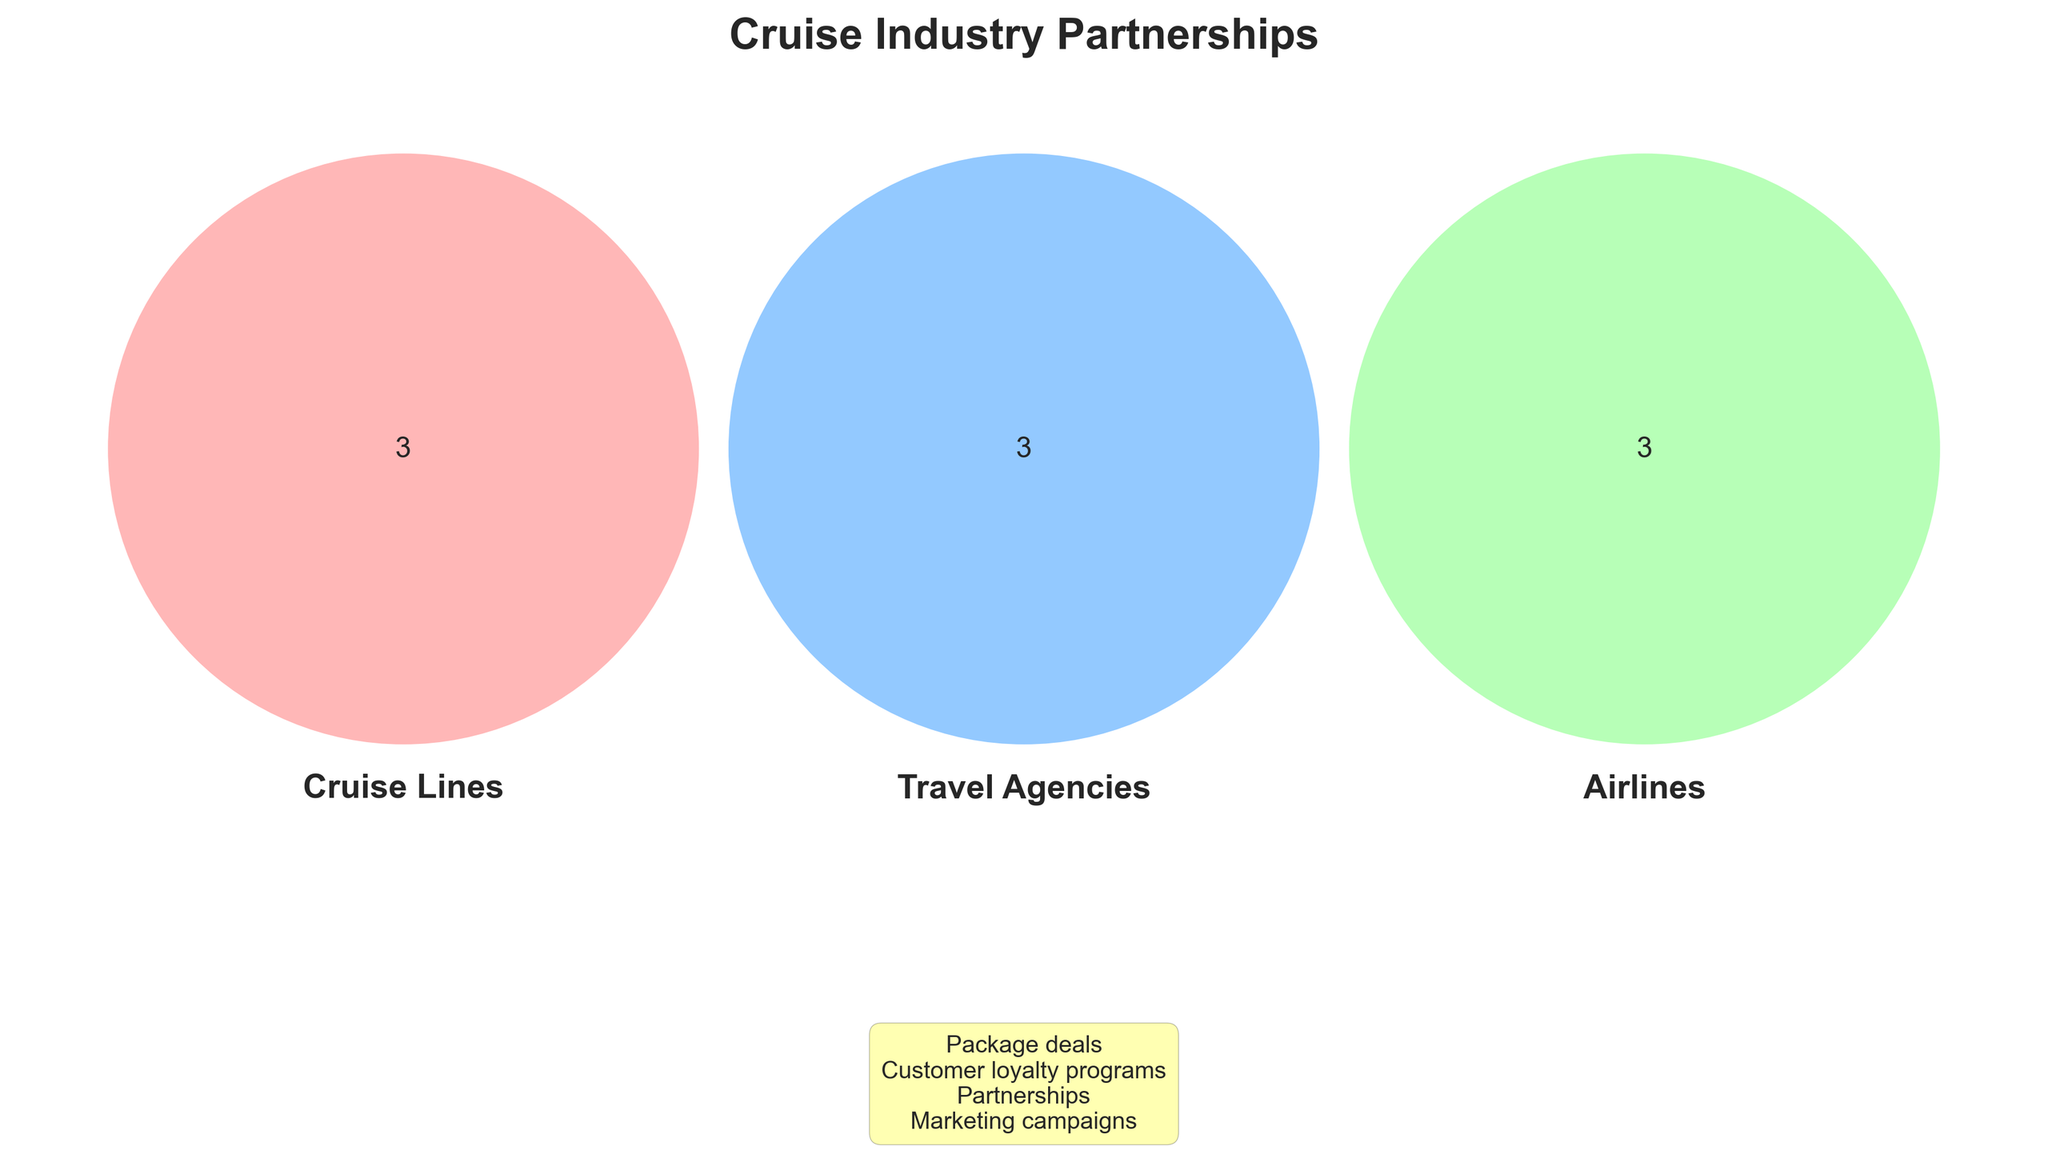What's the title of the Venn Diagram? The title is usually placed at the top of the figure and is in a larger or bolder font compared to the rest of the text. In this case, the title is prominently displayed at the top.
Answer: Cruise Industry Partnerships Which category has the most entities? By counting the entities listed in each category within the Venn Diagram, we can determine which group has more members. Cruise Lines have 3 entities, Travel Agencies have 3, and Airlines have 3. Thus, they all have the same number.
Answer: All categories have the same number of entities List two entities from the Travel Agencies category. By quickly scanning the section labeled 'Travel Agencies' in the Venn Diagram, we observe specific entities. Two of them are Expedia and Booking.com.
Answer: Expedia, Booking.com How many shared items are there in the Venn Diagram? Shared items are typically placed in the overlapping areas or listed separately. Here, they are listed together in a yellow box at the bottom. Counting these gives us the total number.
Answer: 4 What types of shared items are between the categories? The shared items are listed together in a yellow box at the bottom of the Venn Diagram. These include Partnerships, Marketing campaigns, Package deals, and Customer loyalty programs.
Answer: Partnerships, Marketing campaigns, Package deals, Customer loyalty programs 